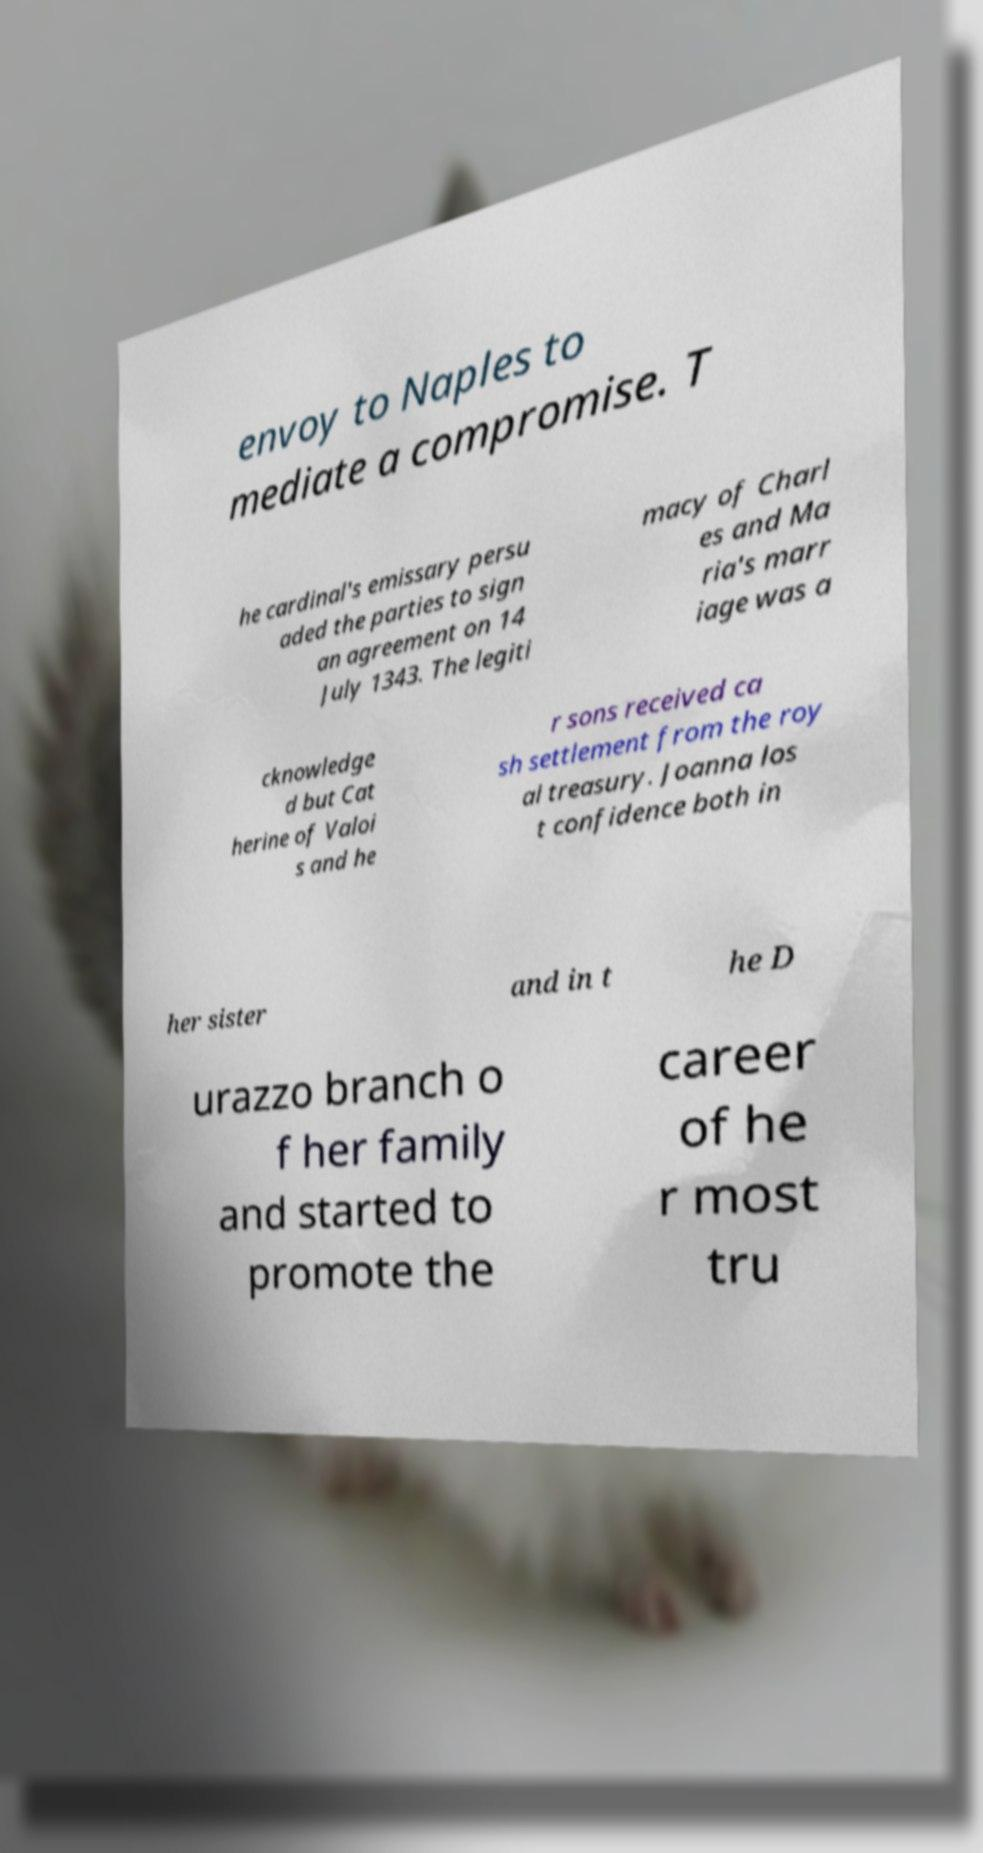Could you extract and type out the text from this image? envoy to Naples to mediate a compromise. T he cardinal's emissary persu aded the parties to sign an agreement on 14 July 1343. The legiti macy of Charl es and Ma ria's marr iage was a cknowledge d but Cat herine of Valoi s and he r sons received ca sh settlement from the roy al treasury. Joanna los t confidence both in her sister and in t he D urazzo branch o f her family and started to promote the career of he r most tru 